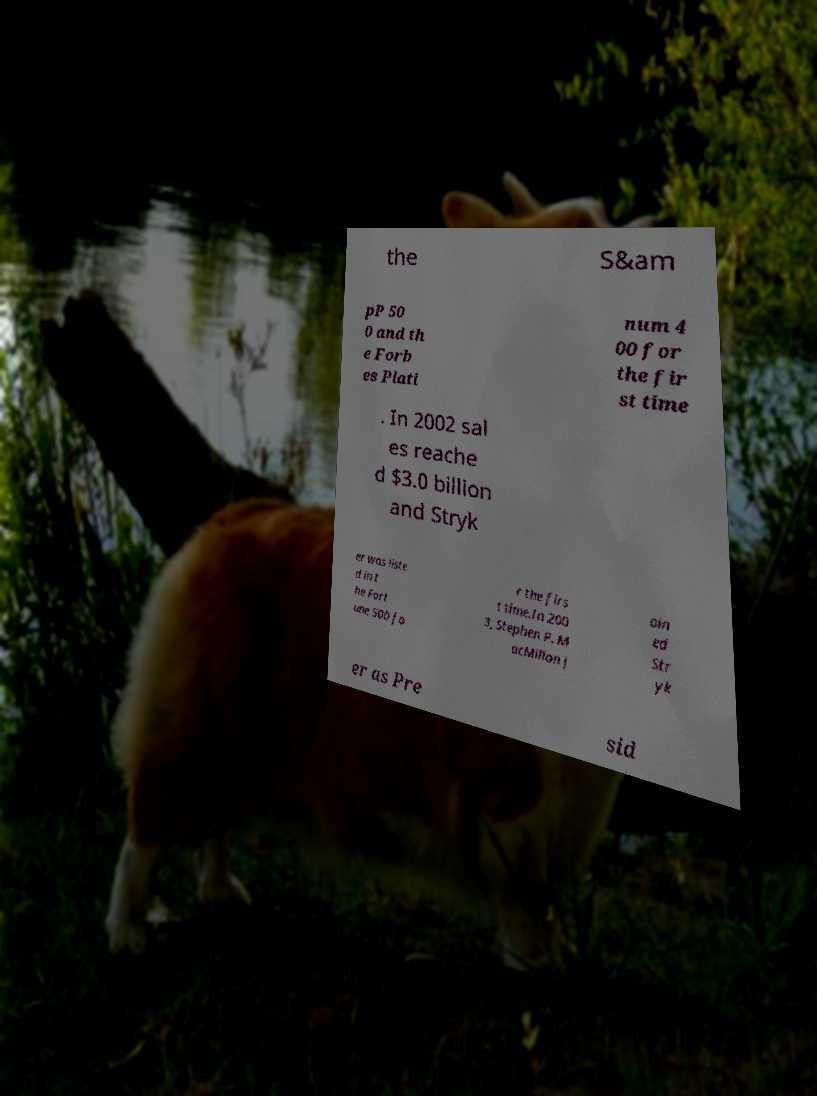Can you read and provide the text displayed in the image?This photo seems to have some interesting text. Can you extract and type it out for me? the S&am pP 50 0 and th e Forb es Plati num 4 00 for the fir st time . In 2002 sal es reache d $3.0 billion and Stryk er was liste d in t he Fort une 500 fo r the firs t time.In 200 3, Stephen P. M acMillan j oin ed Str yk er as Pre sid 